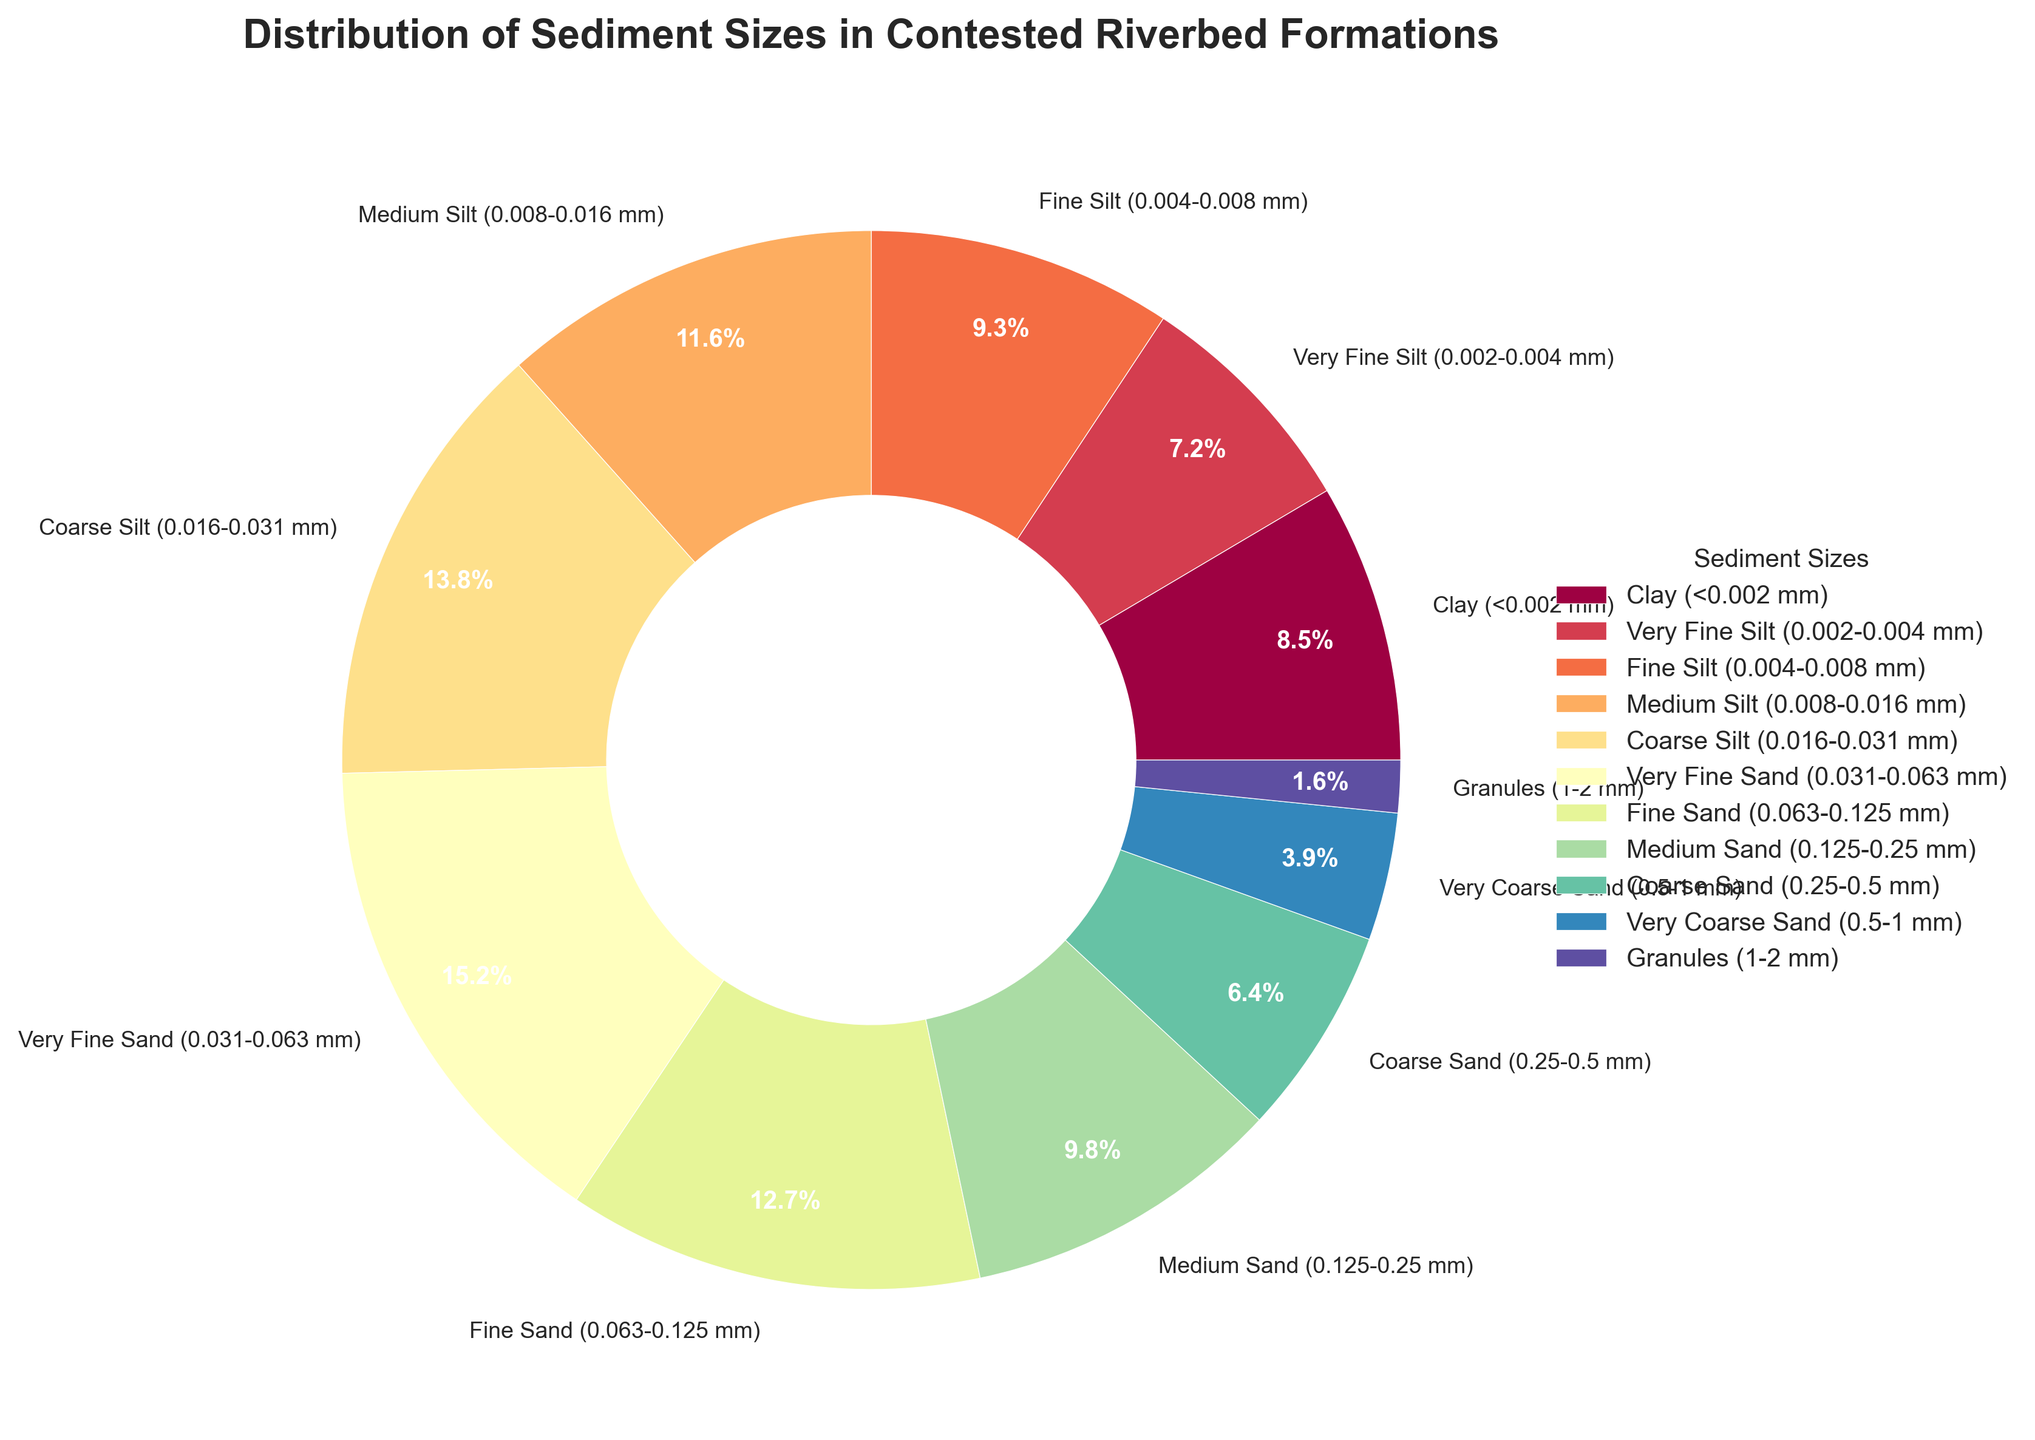What's the total percentage for all types of sand? To find the total percentage for all types of sand, sum the percentages of Very Fine Sand (15.2%), Fine Sand (12.7%), Medium Sand (9.8%), Coarse Sand (6.4%), and Very Coarse Sand (3.9%). The total is 15.2 + 12.7 + 9.8 + 6.4 + 3.9 = 48.0%.
Answer: 48.0% Which sediment size has the smallest percentage? By examining the pie chart, we can identify that Granules (1-2 mm) has the smallest percentage at 1.6%.
Answer: Granules Is the percentage of Medium Silt larger or smaller than the percentage of Fine Sand? The pie chart shows Medium Silt at 11.6% and Fine Sand at 12.7%. Since 11.6% is less than 12.7%, Medium Silt's percentage is smaller.
Answer: Smaller How much larger is the percentage of Very Fine Sand compared to Coarse Sand? The percentage of Very Fine Sand is 15.2% and Coarse Sand is 6.4%. The difference is 15.2% - 6.4% = 8.8%.
Answer: 8.8% What's the combined percentage for all types of silt? Summing the percentages of Very Fine Silt (7.2%), Fine Silt (9.3%), Medium Silt (11.6%), and Coarse Silt (13.8%) gives 7.2 + 9.3 + 11.6 + 13.8 = 41.9%.
Answer: 41.9% What is the percentage gap between the highest and lowest sediment sizes? The highest percentage is 15.2% for Very Fine Sand, and the lowest is 1.6% for Granules. The gap is 15.2% - 1.6% = 13.6%.
Answer: 13.6% Describe the color used for Medium Sand in the pie chart. The chart uses a gradient of colors from a colormap. Noticing the colors, Medium Sand appears in a distinct section with a specific hue, likely a light green or similar shade.
Answer: Light green Compare the percentage of Clay to the combined percentage of all Silt types. Which is greater? Clay has a percentage of 8.5%. The combined percentage of all Silt types (Very Fine Silt, Fine Silt, Medium Silt, Coarse Silt) is 41.9%. Since 41.9% is greater than 8.5%, the combined percentage of all Silt types is greater.
Answer: All Silt types combined 